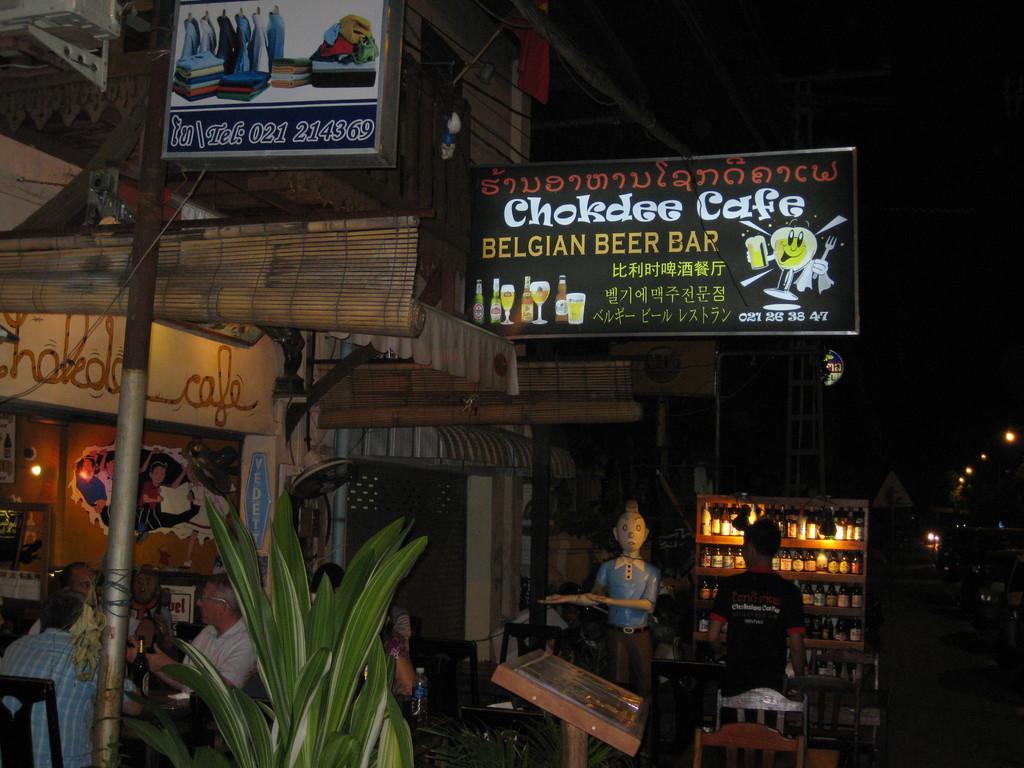Could you give a brief overview of what you see in this image? In this image we can see a restaurant with boards attached to it and some people sitting in front of the restaurant, there is a plant, iron pole with a board, there is a table, chair, a mannequin, a cupboard with bottles in it and a person standing in front of the cupboard. 